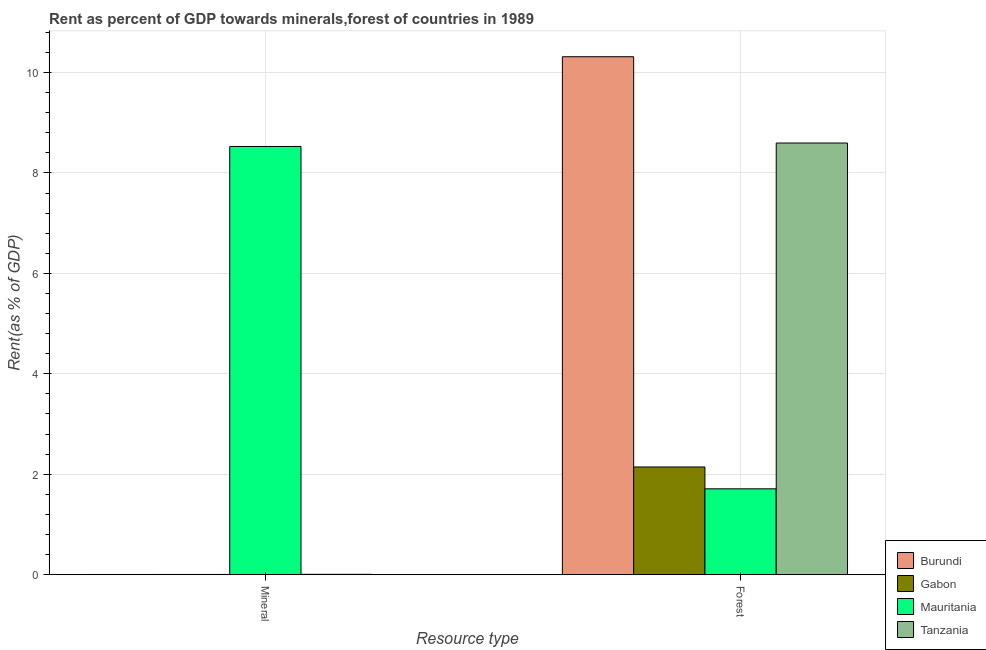Are the number of bars per tick equal to the number of legend labels?
Ensure brevity in your answer.  Yes. How many bars are there on the 2nd tick from the right?
Offer a terse response. 4. What is the label of the 2nd group of bars from the left?
Make the answer very short. Forest. What is the forest rent in Mauritania?
Your response must be concise. 1.71. Across all countries, what is the maximum mineral rent?
Ensure brevity in your answer.  8.53. Across all countries, what is the minimum mineral rent?
Your response must be concise. 0. In which country was the mineral rent maximum?
Provide a succinct answer. Mauritania. In which country was the mineral rent minimum?
Give a very brief answer. Burundi. What is the total forest rent in the graph?
Keep it short and to the point. 22.76. What is the difference between the forest rent in Burundi and that in Tanzania?
Your answer should be compact. 1.72. What is the difference between the mineral rent in Gabon and the forest rent in Tanzania?
Your answer should be compact. -8.59. What is the average forest rent per country?
Keep it short and to the point. 5.69. What is the difference between the forest rent and mineral rent in Burundi?
Provide a succinct answer. 10.31. What is the ratio of the mineral rent in Tanzania to that in Gabon?
Give a very brief answer. 1.49. What does the 1st bar from the left in Mineral represents?
Provide a short and direct response. Burundi. What does the 1st bar from the right in Mineral represents?
Your answer should be very brief. Tanzania. Are all the bars in the graph horizontal?
Your response must be concise. No. How many countries are there in the graph?
Give a very brief answer. 4. Does the graph contain any zero values?
Your answer should be compact. No. Does the graph contain grids?
Offer a terse response. Yes. How many legend labels are there?
Give a very brief answer. 4. How are the legend labels stacked?
Make the answer very short. Vertical. What is the title of the graph?
Provide a succinct answer. Rent as percent of GDP towards minerals,forest of countries in 1989. Does "North America" appear as one of the legend labels in the graph?
Offer a very short reply. No. What is the label or title of the X-axis?
Keep it short and to the point. Resource type. What is the label or title of the Y-axis?
Your answer should be very brief. Rent(as % of GDP). What is the Rent(as % of GDP) in Burundi in Mineral?
Keep it short and to the point. 0. What is the Rent(as % of GDP) in Gabon in Mineral?
Keep it short and to the point. 0. What is the Rent(as % of GDP) of Mauritania in Mineral?
Your answer should be very brief. 8.53. What is the Rent(as % of GDP) of Tanzania in Mineral?
Offer a terse response. 0.01. What is the Rent(as % of GDP) of Burundi in Forest?
Your answer should be very brief. 10.31. What is the Rent(as % of GDP) of Gabon in Forest?
Ensure brevity in your answer.  2.14. What is the Rent(as % of GDP) in Mauritania in Forest?
Give a very brief answer. 1.71. What is the Rent(as % of GDP) in Tanzania in Forest?
Offer a very short reply. 8.59. Across all Resource type, what is the maximum Rent(as % of GDP) of Burundi?
Make the answer very short. 10.31. Across all Resource type, what is the maximum Rent(as % of GDP) of Gabon?
Offer a terse response. 2.14. Across all Resource type, what is the maximum Rent(as % of GDP) of Mauritania?
Ensure brevity in your answer.  8.53. Across all Resource type, what is the maximum Rent(as % of GDP) of Tanzania?
Provide a succinct answer. 8.59. Across all Resource type, what is the minimum Rent(as % of GDP) of Burundi?
Your answer should be compact. 0. Across all Resource type, what is the minimum Rent(as % of GDP) of Gabon?
Offer a terse response. 0. Across all Resource type, what is the minimum Rent(as % of GDP) in Mauritania?
Offer a very short reply. 1.71. Across all Resource type, what is the minimum Rent(as % of GDP) in Tanzania?
Your answer should be very brief. 0.01. What is the total Rent(as % of GDP) in Burundi in the graph?
Make the answer very short. 10.32. What is the total Rent(as % of GDP) in Gabon in the graph?
Give a very brief answer. 2.15. What is the total Rent(as % of GDP) in Mauritania in the graph?
Make the answer very short. 10.24. What is the total Rent(as % of GDP) in Tanzania in the graph?
Your answer should be compact. 8.6. What is the difference between the Rent(as % of GDP) in Burundi in Mineral and that in Forest?
Your response must be concise. -10.31. What is the difference between the Rent(as % of GDP) of Gabon in Mineral and that in Forest?
Make the answer very short. -2.14. What is the difference between the Rent(as % of GDP) of Mauritania in Mineral and that in Forest?
Your answer should be very brief. 6.82. What is the difference between the Rent(as % of GDP) in Tanzania in Mineral and that in Forest?
Make the answer very short. -8.59. What is the difference between the Rent(as % of GDP) of Burundi in Mineral and the Rent(as % of GDP) of Gabon in Forest?
Provide a succinct answer. -2.14. What is the difference between the Rent(as % of GDP) of Burundi in Mineral and the Rent(as % of GDP) of Mauritania in Forest?
Provide a succinct answer. -1.71. What is the difference between the Rent(as % of GDP) in Burundi in Mineral and the Rent(as % of GDP) in Tanzania in Forest?
Your response must be concise. -8.59. What is the difference between the Rent(as % of GDP) of Gabon in Mineral and the Rent(as % of GDP) of Mauritania in Forest?
Offer a very short reply. -1.71. What is the difference between the Rent(as % of GDP) of Gabon in Mineral and the Rent(as % of GDP) of Tanzania in Forest?
Provide a short and direct response. -8.59. What is the difference between the Rent(as % of GDP) in Mauritania in Mineral and the Rent(as % of GDP) in Tanzania in Forest?
Provide a succinct answer. -0.07. What is the average Rent(as % of GDP) in Burundi per Resource type?
Offer a terse response. 5.16. What is the average Rent(as % of GDP) of Gabon per Resource type?
Provide a succinct answer. 1.07. What is the average Rent(as % of GDP) in Mauritania per Resource type?
Provide a succinct answer. 5.12. What is the average Rent(as % of GDP) of Tanzania per Resource type?
Keep it short and to the point. 4.3. What is the difference between the Rent(as % of GDP) in Burundi and Rent(as % of GDP) in Gabon in Mineral?
Keep it short and to the point. -0. What is the difference between the Rent(as % of GDP) in Burundi and Rent(as % of GDP) in Mauritania in Mineral?
Provide a short and direct response. -8.52. What is the difference between the Rent(as % of GDP) of Burundi and Rent(as % of GDP) of Tanzania in Mineral?
Ensure brevity in your answer.  -0. What is the difference between the Rent(as % of GDP) of Gabon and Rent(as % of GDP) of Mauritania in Mineral?
Keep it short and to the point. -8.52. What is the difference between the Rent(as % of GDP) in Gabon and Rent(as % of GDP) in Tanzania in Mineral?
Your answer should be very brief. -0. What is the difference between the Rent(as % of GDP) of Mauritania and Rent(as % of GDP) of Tanzania in Mineral?
Your response must be concise. 8.52. What is the difference between the Rent(as % of GDP) in Burundi and Rent(as % of GDP) in Gabon in Forest?
Give a very brief answer. 8.17. What is the difference between the Rent(as % of GDP) in Burundi and Rent(as % of GDP) in Mauritania in Forest?
Provide a short and direct response. 8.6. What is the difference between the Rent(as % of GDP) of Burundi and Rent(as % of GDP) of Tanzania in Forest?
Offer a very short reply. 1.72. What is the difference between the Rent(as % of GDP) in Gabon and Rent(as % of GDP) in Mauritania in Forest?
Give a very brief answer. 0.43. What is the difference between the Rent(as % of GDP) of Gabon and Rent(as % of GDP) of Tanzania in Forest?
Your answer should be very brief. -6.45. What is the difference between the Rent(as % of GDP) of Mauritania and Rent(as % of GDP) of Tanzania in Forest?
Provide a short and direct response. -6.89. What is the ratio of the Rent(as % of GDP) of Gabon in Mineral to that in Forest?
Keep it short and to the point. 0. What is the ratio of the Rent(as % of GDP) of Mauritania in Mineral to that in Forest?
Give a very brief answer. 4.99. What is the ratio of the Rent(as % of GDP) in Tanzania in Mineral to that in Forest?
Keep it short and to the point. 0. What is the difference between the highest and the second highest Rent(as % of GDP) of Burundi?
Keep it short and to the point. 10.31. What is the difference between the highest and the second highest Rent(as % of GDP) in Gabon?
Ensure brevity in your answer.  2.14. What is the difference between the highest and the second highest Rent(as % of GDP) in Mauritania?
Give a very brief answer. 6.82. What is the difference between the highest and the second highest Rent(as % of GDP) of Tanzania?
Provide a succinct answer. 8.59. What is the difference between the highest and the lowest Rent(as % of GDP) of Burundi?
Keep it short and to the point. 10.31. What is the difference between the highest and the lowest Rent(as % of GDP) in Gabon?
Give a very brief answer. 2.14. What is the difference between the highest and the lowest Rent(as % of GDP) of Mauritania?
Your answer should be compact. 6.82. What is the difference between the highest and the lowest Rent(as % of GDP) in Tanzania?
Provide a succinct answer. 8.59. 